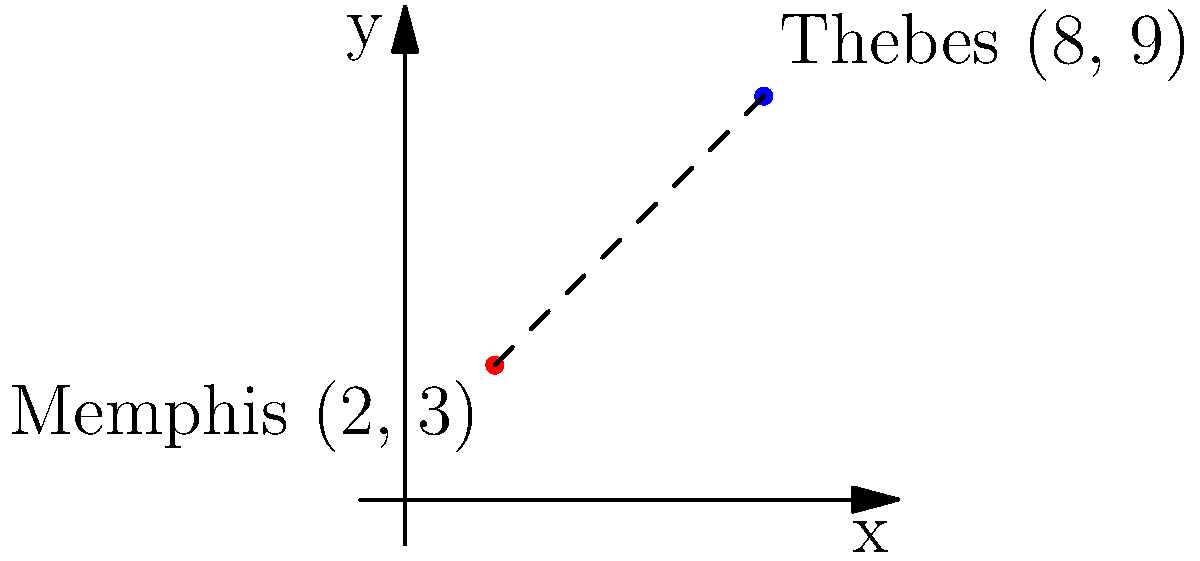In your study of ancient Egyptian cities, you've plotted the locations of Memphis and Thebes on a coordinate plane. Memphis is located at (2, 3) and Thebes at (8, 9). Using the distance formula, calculate the straight-line distance between these two important cities. Round your answer to the nearest tenth of a unit. To solve this problem, we'll use the distance formula derived from the Pythagorean theorem:

$$d = \sqrt{(x_2 - x_1)^2 + (y_2 - y_1)^2}$$

Where $(x_1, y_1)$ represents the coordinates of Memphis (2, 3) and $(x_2, y_2)$ represents the coordinates of Thebes (8, 9).

Step 1: Identify the coordinates
Memphis: $(x_1, y_1) = (2, 3)$
Thebes: $(x_2, y_2) = (8, 9)$

Step 2: Plug the coordinates into the distance formula
$$d = \sqrt{(8 - 2)^2 + (9 - 3)^2}$$

Step 3: Simplify the expressions inside the parentheses
$$d = \sqrt{6^2 + 6^2}$$

Step 4: Calculate the squares
$$d = \sqrt{36 + 36}$$

Step 5: Add under the square root
$$d = \sqrt{72}$$

Step 6: Simplify the square root
$$d = 6\sqrt{2}$$

Step 7: Calculate the approximate value and round to the nearest tenth
$$d \approx 8.5$$

Therefore, the distance between Memphis and Thebes is approximately 8.5 units.
Answer: 8.5 units 